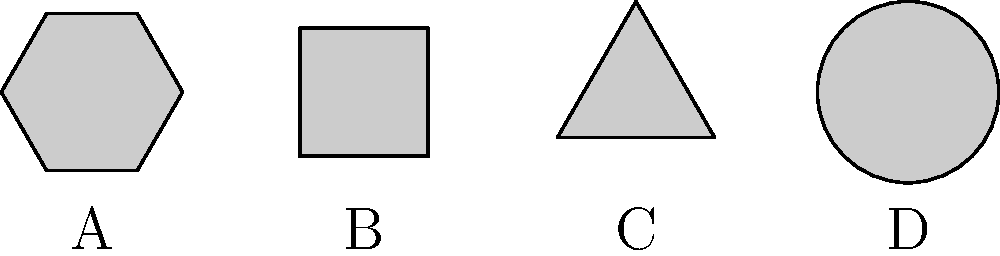In tactical communication, rotational symmetry of symbols is crucial for quick recognition. Consider the set of symbols above, used in a classified military operation. If we define a group operation based on the order of rotational symmetry, which symbol would serve as the identity element, and what is the order of this group? To solve this problem, we need to follow these steps:

1. Identify the order of rotational symmetry for each symbol:
   A (Hexagon): 6
   B (Square): 4
   C (Triangle): 3
   D (Circle): Infinite

2. The group operation is based on the order of rotational symmetry. In group theory, the identity element is the element that, when combined with any other element, leaves that element unchanged.

3. In this case, the symbol with the lowest order of rotational symmetry would serve as the identity element, as it would not increase the order of symmetry when combined with other symbols.

4. The triangle (Symbol C) has the lowest finite order of rotational symmetry (3), so it serves as the identity element.

5. To determine the order of the group, we need to find the least common multiple (LCM) of all the finite orders of rotational symmetry:
   LCM(6, 4, 3) = 12

6. The circle (Symbol D) has infinite rotational symmetry, which doesn't affect the LCM calculation but is included as an element in the group.

Therefore, the order of this group is 12, with the triangle serving as the identity element.
Answer: Identity: Triangle (C); Group order: 12 